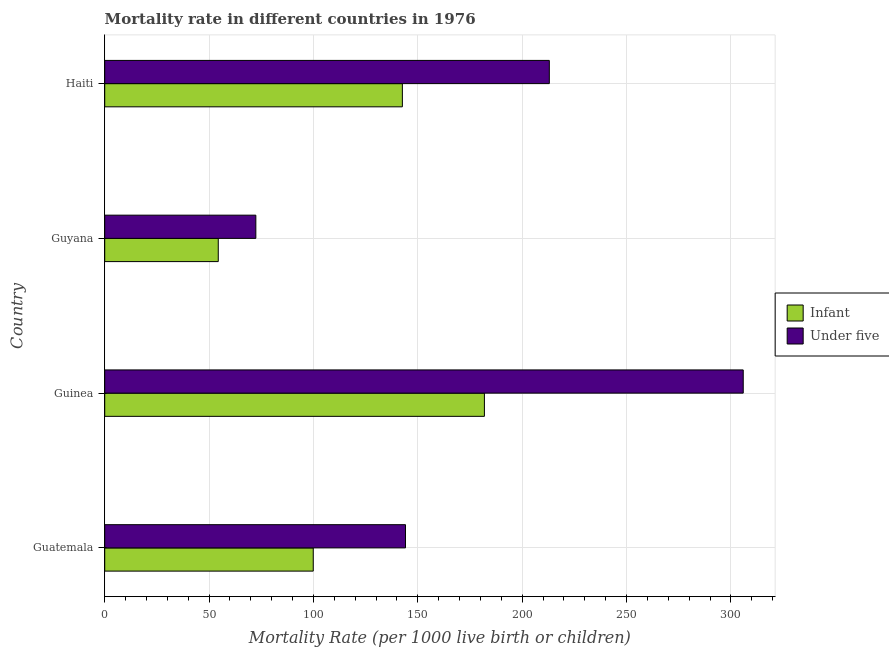Are the number of bars per tick equal to the number of legend labels?
Make the answer very short. Yes. How many bars are there on the 4th tick from the top?
Your answer should be very brief. 2. How many bars are there on the 1st tick from the bottom?
Make the answer very short. 2. What is the label of the 1st group of bars from the top?
Your answer should be very brief. Haiti. What is the infant mortality rate in Haiti?
Your answer should be very brief. 142.6. Across all countries, what is the maximum infant mortality rate?
Offer a terse response. 181.9. Across all countries, what is the minimum under-5 mortality rate?
Your answer should be compact. 72.4. In which country was the infant mortality rate maximum?
Keep it short and to the point. Guinea. In which country was the under-5 mortality rate minimum?
Your answer should be compact. Guyana. What is the total infant mortality rate in the graph?
Give a very brief answer. 478.8. What is the difference between the infant mortality rate in Guyana and that in Haiti?
Offer a terse response. -88.2. What is the difference between the infant mortality rate in Guatemala and the under-5 mortality rate in Guyana?
Give a very brief answer. 27.5. What is the average infant mortality rate per country?
Your response must be concise. 119.7. What is the difference between the infant mortality rate and under-5 mortality rate in Guinea?
Offer a very short reply. -124. What is the ratio of the infant mortality rate in Guyana to that in Haiti?
Ensure brevity in your answer.  0.38. What is the difference between the highest and the second highest infant mortality rate?
Offer a terse response. 39.3. What is the difference between the highest and the lowest infant mortality rate?
Offer a very short reply. 127.5. In how many countries, is the under-5 mortality rate greater than the average under-5 mortality rate taken over all countries?
Your response must be concise. 2. Is the sum of the infant mortality rate in Guatemala and Guinea greater than the maximum under-5 mortality rate across all countries?
Offer a terse response. No. What does the 2nd bar from the top in Guyana represents?
Keep it short and to the point. Infant. What does the 1st bar from the bottom in Haiti represents?
Your answer should be compact. Infant. Are all the bars in the graph horizontal?
Make the answer very short. Yes. What is the difference between two consecutive major ticks on the X-axis?
Provide a succinct answer. 50. Are the values on the major ticks of X-axis written in scientific E-notation?
Provide a succinct answer. No. How many legend labels are there?
Your response must be concise. 2. What is the title of the graph?
Keep it short and to the point. Mortality rate in different countries in 1976. What is the label or title of the X-axis?
Your response must be concise. Mortality Rate (per 1000 live birth or children). What is the label or title of the Y-axis?
Your answer should be very brief. Country. What is the Mortality Rate (per 1000 live birth or children) in Infant in Guatemala?
Make the answer very short. 99.9. What is the Mortality Rate (per 1000 live birth or children) in Under five in Guatemala?
Your response must be concise. 144.1. What is the Mortality Rate (per 1000 live birth or children) in Infant in Guinea?
Your answer should be compact. 181.9. What is the Mortality Rate (per 1000 live birth or children) in Under five in Guinea?
Offer a terse response. 305.9. What is the Mortality Rate (per 1000 live birth or children) of Infant in Guyana?
Your answer should be compact. 54.4. What is the Mortality Rate (per 1000 live birth or children) of Under five in Guyana?
Your answer should be compact. 72.4. What is the Mortality Rate (per 1000 live birth or children) in Infant in Haiti?
Give a very brief answer. 142.6. What is the Mortality Rate (per 1000 live birth or children) in Under five in Haiti?
Provide a succinct answer. 213. Across all countries, what is the maximum Mortality Rate (per 1000 live birth or children) in Infant?
Your response must be concise. 181.9. Across all countries, what is the maximum Mortality Rate (per 1000 live birth or children) in Under five?
Offer a terse response. 305.9. Across all countries, what is the minimum Mortality Rate (per 1000 live birth or children) of Infant?
Your answer should be very brief. 54.4. Across all countries, what is the minimum Mortality Rate (per 1000 live birth or children) in Under five?
Keep it short and to the point. 72.4. What is the total Mortality Rate (per 1000 live birth or children) of Infant in the graph?
Your response must be concise. 478.8. What is the total Mortality Rate (per 1000 live birth or children) of Under five in the graph?
Provide a short and direct response. 735.4. What is the difference between the Mortality Rate (per 1000 live birth or children) in Infant in Guatemala and that in Guinea?
Your answer should be compact. -82. What is the difference between the Mortality Rate (per 1000 live birth or children) of Under five in Guatemala and that in Guinea?
Your answer should be compact. -161.8. What is the difference between the Mortality Rate (per 1000 live birth or children) in Infant in Guatemala and that in Guyana?
Your answer should be very brief. 45.5. What is the difference between the Mortality Rate (per 1000 live birth or children) in Under five in Guatemala and that in Guyana?
Offer a very short reply. 71.7. What is the difference between the Mortality Rate (per 1000 live birth or children) in Infant in Guatemala and that in Haiti?
Make the answer very short. -42.7. What is the difference between the Mortality Rate (per 1000 live birth or children) in Under five in Guatemala and that in Haiti?
Offer a terse response. -68.9. What is the difference between the Mortality Rate (per 1000 live birth or children) of Infant in Guinea and that in Guyana?
Provide a succinct answer. 127.5. What is the difference between the Mortality Rate (per 1000 live birth or children) in Under five in Guinea and that in Guyana?
Your answer should be compact. 233.5. What is the difference between the Mortality Rate (per 1000 live birth or children) in Infant in Guinea and that in Haiti?
Give a very brief answer. 39.3. What is the difference between the Mortality Rate (per 1000 live birth or children) in Under five in Guinea and that in Haiti?
Make the answer very short. 92.9. What is the difference between the Mortality Rate (per 1000 live birth or children) of Infant in Guyana and that in Haiti?
Keep it short and to the point. -88.2. What is the difference between the Mortality Rate (per 1000 live birth or children) of Under five in Guyana and that in Haiti?
Offer a terse response. -140.6. What is the difference between the Mortality Rate (per 1000 live birth or children) in Infant in Guatemala and the Mortality Rate (per 1000 live birth or children) in Under five in Guinea?
Offer a terse response. -206. What is the difference between the Mortality Rate (per 1000 live birth or children) in Infant in Guatemala and the Mortality Rate (per 1000 live birth or children) in Under five in Haiti?
Your answer should be very brief. -113.1. What is the difference between the Mortality Rate (per 1000 live birth or children) in Infant in Guinea and the Mortality Rate (per 1000 live birth or children) in Under five in Guyana?
Ensure brevity in your answer.  109.5. What is the difference between the Mortality Rate (per 1000 live birth or children) in Infant in Guinea and the Mortality Rate (per 1000 live birth or children) in Under five in Haiti?
Your answer should be very brief. -31.1. What is the difference between the Mortality Rate (per 1000 live birth or children) of Infant in Guyana and the Mortality Rate (per 1000 live birth or children) of Under five in Haiti?
Your answer should be compact. -158.6. What is the average Mortality Rate (per 1000 live birth or children) of Infant per country?
Offer a very short reply. 119.7. What is the average Mortality Rate (per 1000 live birth or children) of Under five per country?
Your answer should be compact. 183.85. What is the difference between the Mortality Rate (per 1000 live birth or children) in Infant and Mortality Rate (per 1000 live birth or children) in Under five in Guatemala?
Offer a terse response. -44.2. What is the difference between the Mortality Rate (per 1000 live birth or children) in Infant and Mortality Rate (per 1000 live birth or children) in Under five in Guinea?
Ensure brevity in your answer.  -124. What is the difference between the Mortality Rate (per 1000 live birth or children) in Infant and Mortality Rate (per 1000 live birth or children) in Under five in Haiti?
Provide a short and direct response. -70.4. What is the ratio of the Mortality Rate (per 1000 live birth or children) of Infant in Guatemala to that in Guinea?
Offer a very short reply. 0.55. What is the ratio of the Mortality Rate (per 1000 live birth or children) of Under five in Guatemala to that in Guinea?
Provide a succinct answer. 0.47. What is the ratio of the Mortality Rate (per 1000 live birth or children) in Infant in Guatemala to that in Guyana?
Your answer should be compact. 1.84. What is the ratio of the Mortality Rate (per 1000 live birth or children) of Under five in Guatemala to that in Guyana?
Give a very brief answer. 1.99. What is the ratio of the Mortality Rate (per 1000 live birth or children) in Infant in Guatemala to that in Haiti?
Your answer should be very brief. 0.7. What is the ratio of the Mortality Rate (per 1000 live birth or children) of Under five in Guatemala to that in Haiti?
Ensure brevity in your answer.  0.68. What is the ratio of the Mortality Rate (per 1000 live birth or children) of Infant in Guinea to that in Guyana?
Your answer should be very brief. 3.34. What is the ratio of the Mortality Rate (per 1000 live birth or children) of Under five in Guinea to that in Guyana?
Offer a terse response. 4.23. What is the ratio of the Mortality Rate (per 1000 live birth or children) in Infant in Guinea to that in Haiti?
Give a very brief answer. 1.28. What is the ratio of the Mortality Rate (per 1000 live birth or children) of Under five in Guinea to that in Haiti?
Give a very brief answer. 1.44. What is the ratio of the Mortality Rate (per 1000 live birth or children) of Infant in Guyana to that in Haiti?
Ensure brevity in your answer.  0.38. What is the ratio of the Mortality Rate (per 1000 live birth or children) in Under five in Guyana to that in Haiti?
Offer a very short reply. 0.34. What is the difference between the highest and the second highest Mortality Rate (per 1000 live birth or children) in Infant?
Offer a very short reply. 39.3. What is the difference between the highest and the second highest Mortality Rate (per 1000 live birth or children) in Under five?
Your answer should be very brief. 92.9. What is the difference between the highest and the lowest Mortality Rate (per 1000 live birth or children) in Infant?
Provide a succinct answer. 127.5. What is the difference between the highest and the lowest Mortality Rate (per 1000 live birth or children) in Under five?
Offer a very short reply. 233.5. 